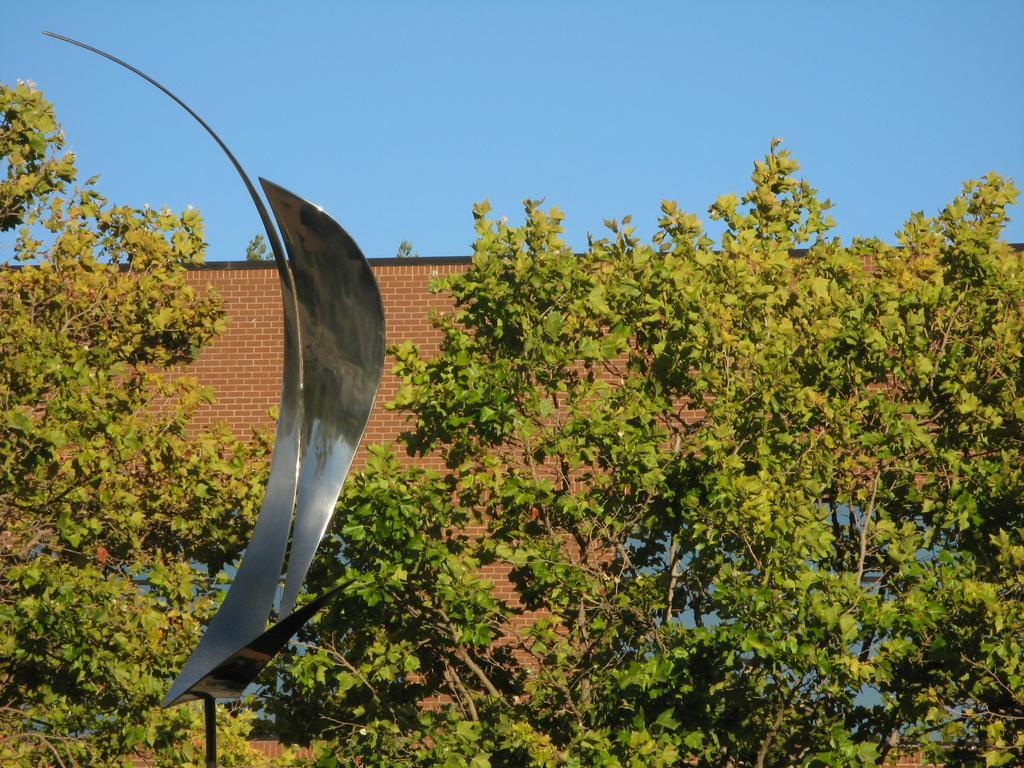Could you give a brief overview of what you see in this image? In the image we can see brick wall, trees, metal object and the sky. 